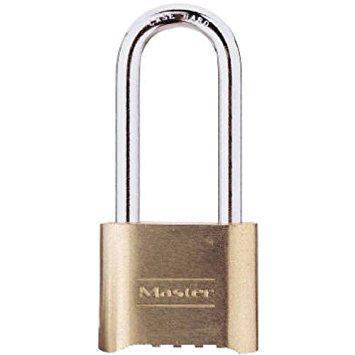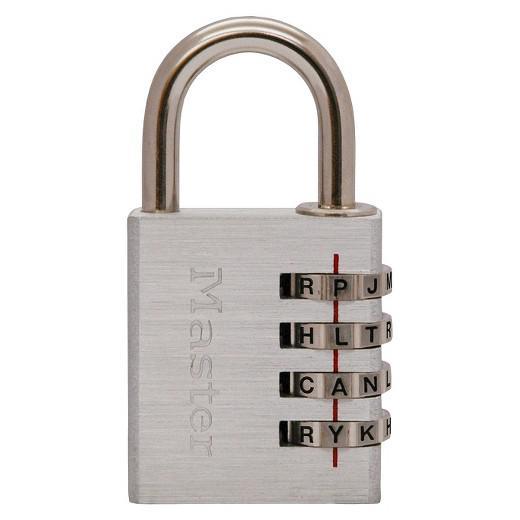The first image is the image on the left, the second image is the image on the right. For the images displayed, is the sentence "One lock is gold and squarish, and the other lock is round with a black face." factually correct? Answer yes or no. No. The first image is the image on the left, the second image is the image on the right. Analyze the images presented: Is the assertion "Each of two different colored padlocks is a similar shape, but one has number belts on the front and side, while the other has number belts on the bottom." valid? Answer yes or no. Yes. 